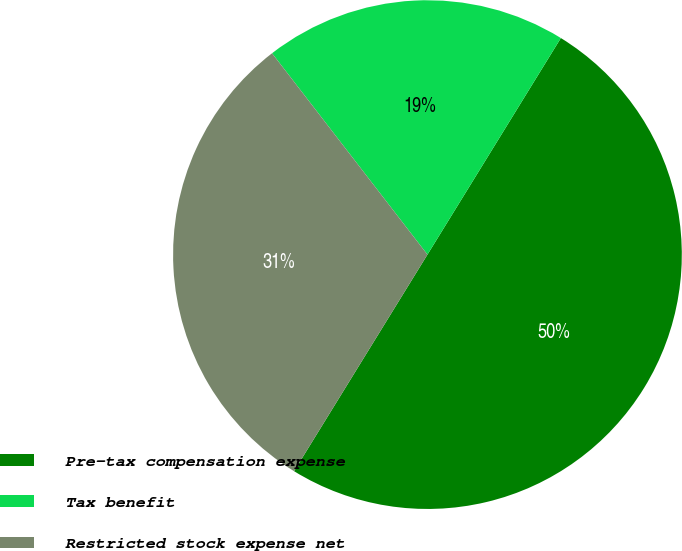Convert chart. <chart><loc_0><loc_0><loc_500><loc_500><pie_chart><fcel>Pre-tax compensation expense<fcel>Tax benefit<fcel>Restricted stock expense net<nl><fcel>50.0%<fcel>19.25%<fcel>30.75%<nl></chart> 